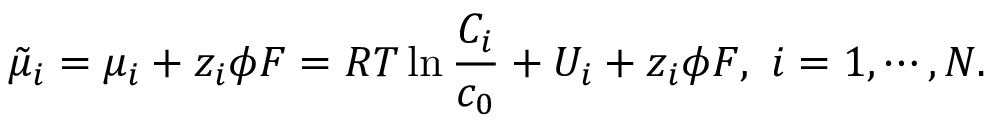Convert formula to latex. <formula><loc_0><loc_0><loc_500><loc_500>\tilde { \mu } _ { i } = \mu _ { i } + z _ { i } \phi F = R T \ln \frac { C _ { i } } { c _ { 0 } } + U _ { i } + z _ { i } \phi F , i = 1 , \cdots , N .</formula> 